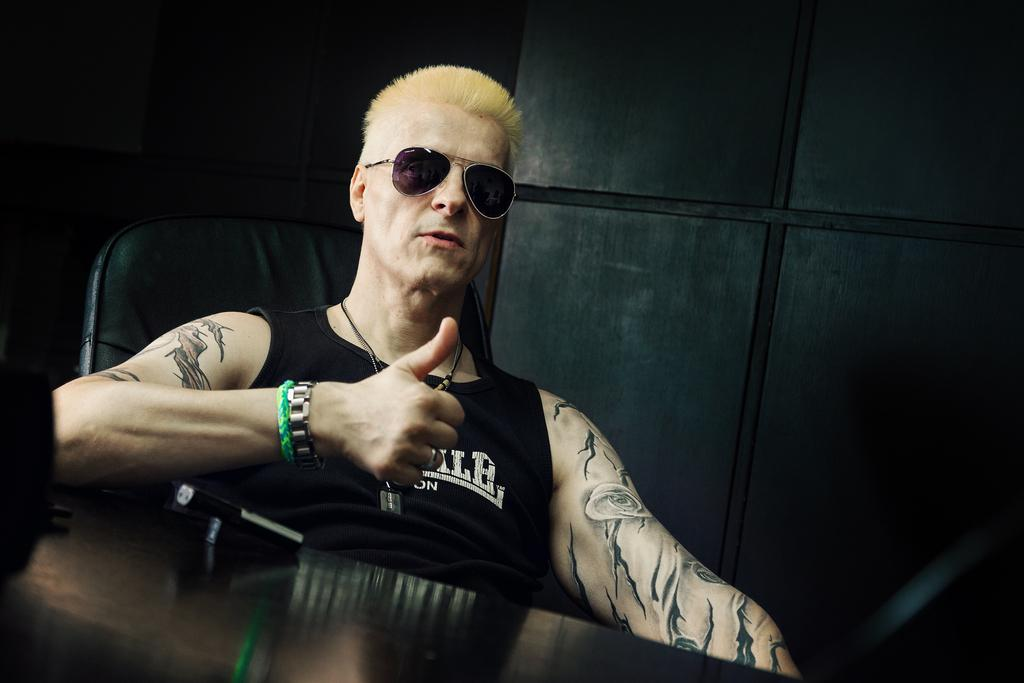Who is the main subject in the image? There is a man in the image. What is the man doing in the image? The man is sitting on a chair. What is the man wearing in the image? The man is wearing a black t-shirt and goggles. What gesture is the man making in the image? The man is showing his thumb. What type of riddle is the man solving in the image? There is no riddle present in the image; the man is simply sitting on a chair and showing his thumb. Can you tell me how many lamps are visible in the image? There are no lamps visible in the image. 